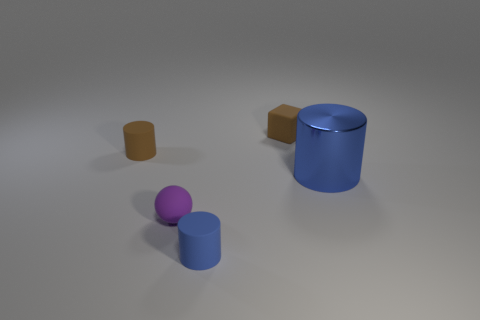Add 1 tiny gray cylinders. How many objects exist? 6 Subtract all cylinders. How many objects are left? 2 Subtract all brown rubber cylinders. Subtract all red things. How many objects are left? 4 Add 5 cylinders. How many cylinders are left? 8 Add 3 matte balls. How many matte balls exist? 4 Subtract 0 gray cylinders. How many objects are left? 5 